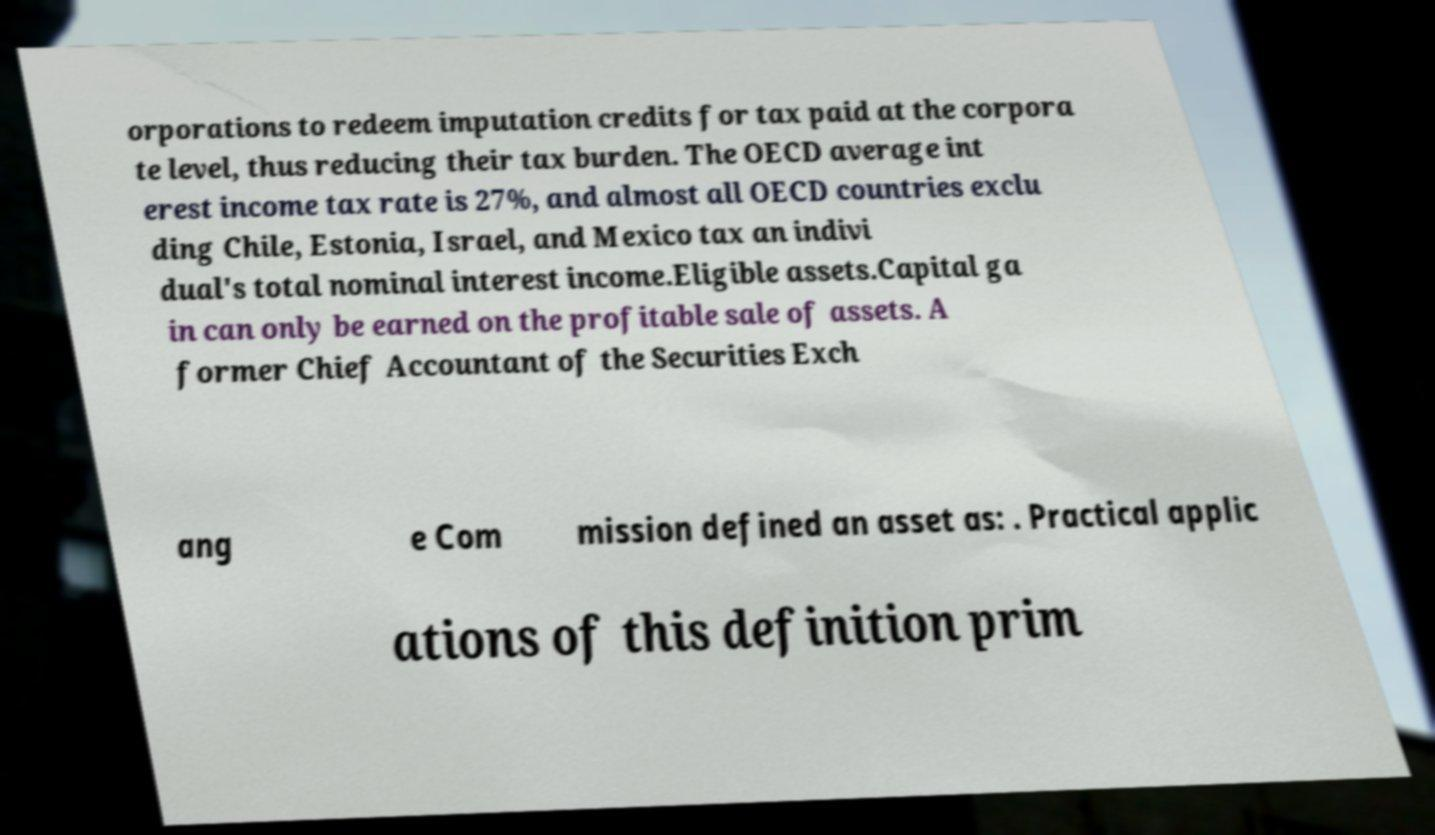Please read and relay the text visible in this image. What does it say? orporations to redeem imputation credits for tax paid at the corpora te level, thus reducing their tax burden. The OECD average int erest income tax rate is 27%, and almost all OECD countries exclu ding Chile, Estonia, Israel, and Mexico tax an indivi dual's total nominal interest income.Eligible assets.Capital ga in can only be earned on the profitable sale of assets. A former Chief Accountant of the Securities Exch ang e Com mission defined an asset as: . Practical applic ations of this definition prim 